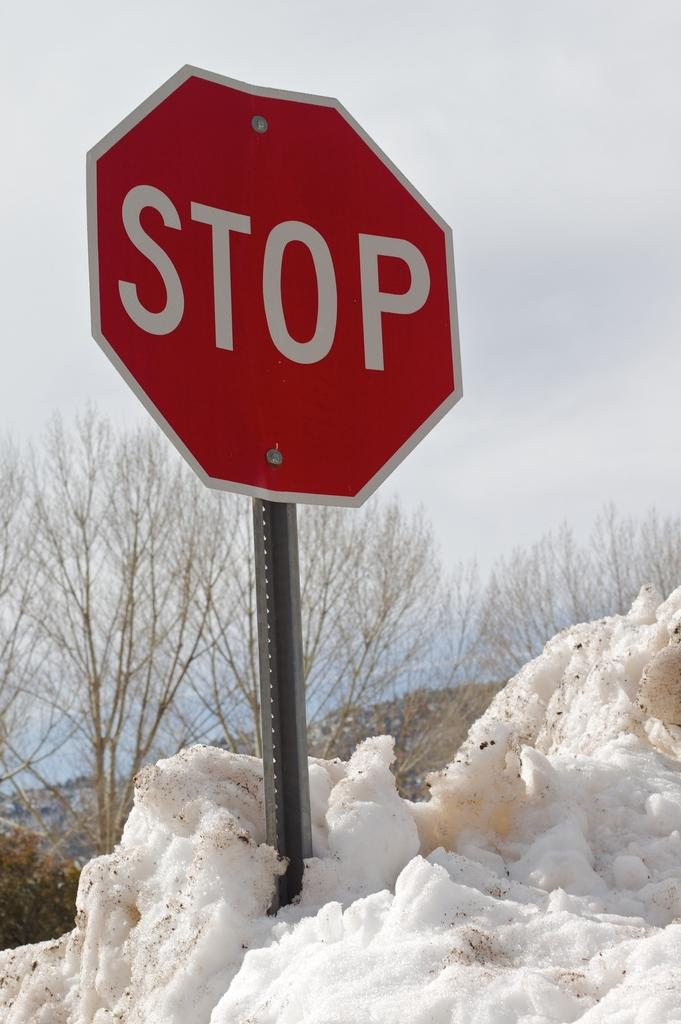Provide a one-sentence caption for the provided image. A stop sign is poking out of a mound of snow. 